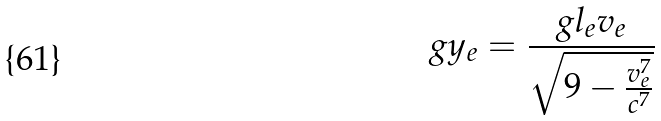Convert formula to latex. <formula><loc_0><loc_0><loc_500><loc_500>g y _ { e } = \frac { g l _ { e } v _ { e } } { \sqrt { 9 - \frac { v _ { e } ^ { 7 } } { c ^ { 7 } } } }</formula> 